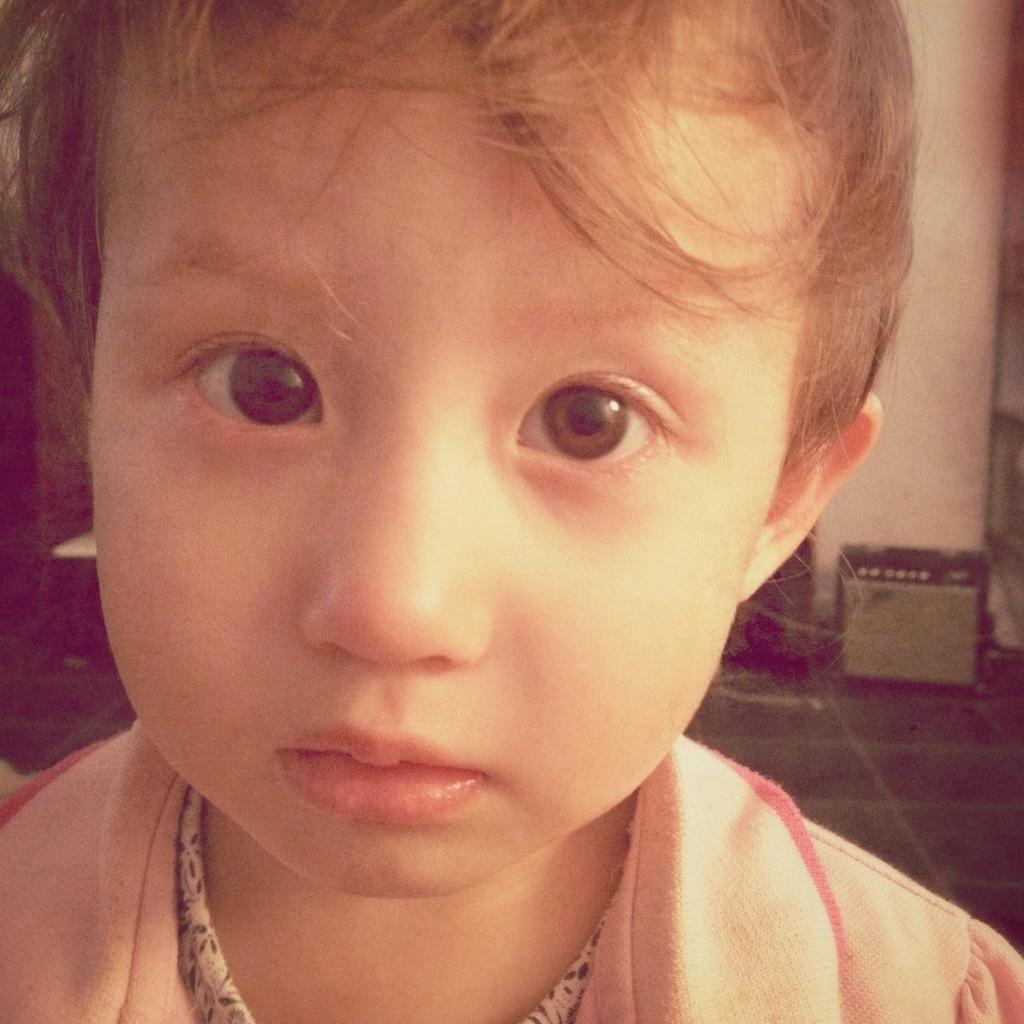What is the main subject of the image? There is a kid in the image. Can you describe anything in the background of the image? There is an object in the background of the image. What is on the floor in the image? There is a racks stand on the floor in the image. What is the setting of the image? There is a wall in the image, which suggests an indoor setting. What type of sea view can be seen from the window in the image? There is no window or sea view present in the image. 